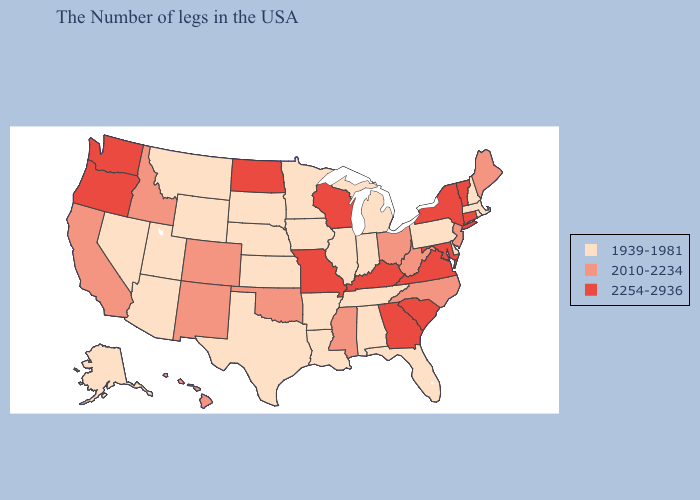Which states have the lowest value in the USA?
Write a very short answer. Massachusetts, Rhode Island, New Hampshire, Delaware, Pennsylvania, Florida, Michigan, Indiana, Alabama, Tennessee, Illinois, Louisiana, Arkansas, Minnesota, Iowa, Kansas, Nebraska, Texas, South Dakota, Wyoming, Utah, Montana, Arizona, Nevada, Alaska. What is the highest value in the USA?
Short answer required. 2254-2936. Does Maine have the lowest value in the Northeast?
Write a very short answer. No. What is the value of Ohio?
Give a very brief answer. 2010-2234. Does Connecticut have the same value as Michigan?
Keep it brief. No. What is the highest value in the USA?
Write a very short answer. 2254-2936. Does Louisiana have the lowest value in the USA?
Quick response, please. Yes. What is the lowest value in states that border New Hampshire?
Write a very short answer. 1939-1981. Which states hav the highest value in the Northeast?
Answer briefly. Vermont, Connecticut, New York. Is the legend a continuous bar?
Answer briefly. No. Is the legend a continuous bar?
Keep it brief. No. Does the first symbol in the legend represent the smallest category?
Quick response, please. Yes. What is the value of Alabama?
Concise answer only. 1939-1981. Name the states that have a value in the range 2010-2234?
Be succinct. Maine, New Jersey, North Carolina, West Virginia, Ohio, Mississippi, Oklahoma, Colorado, New Mexico, Idaho, California, Hawaii. 